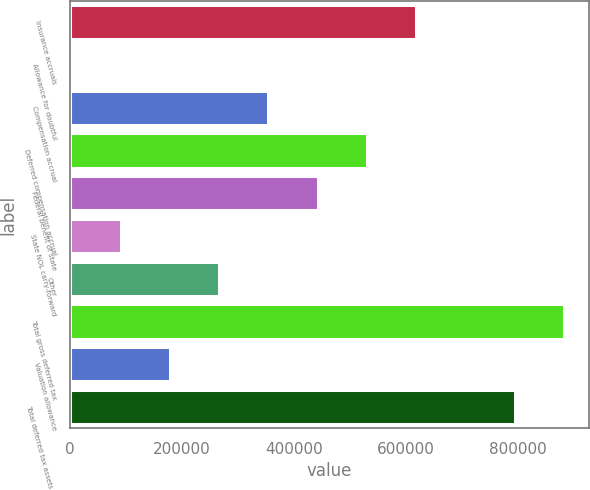Convert chart. <chart><loc_0><loc_0><loc_500><loc_500><bar_chart><fcel>Insurance accruals<fcel>Allowance for doubtful<fcel>Compensation accrual<fcel>Deferred compensation accrual<fcel>Federal benefit of state<fcel>State NOL carry-forward<fcel>Other<fcel>Total gross deferred tax<fcel>Valuation allowance<fcel>Total deferred tax assets net<nl><fcel>618252<fcel>2347<fcel>354293<fcel>530266<fcel>442280<fcel>90333.5<fcel>266306<fcel>882212<fcel>178320<fcel>794226<nl></chart> 